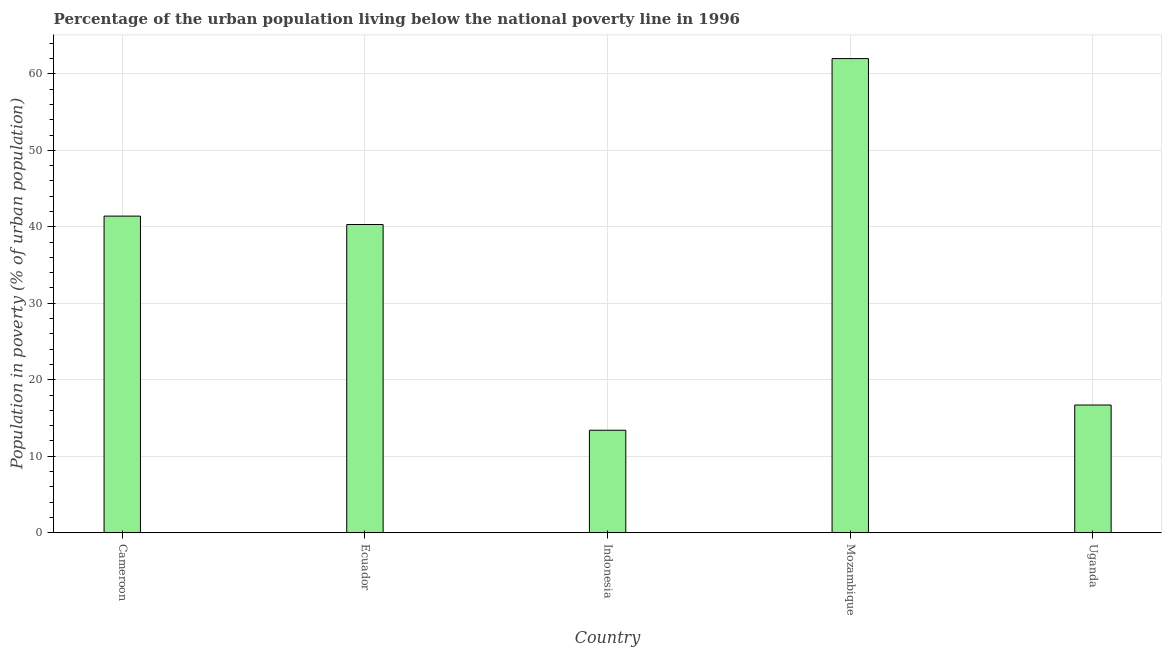Does the graph contain grids?
Make the answer very short. Yes. What is the title of the graph?
Offer a terse response. Percentage of the urban population living below the national poverty line in 1996. What is the label or title of the X-axis?
Offer a very short reply. Country. What is the label or title of the Y-axis?
Offer a terse response. Population in poverty (% of urban population). Across all countries, what is the maximum percentage of urban population living below poverty line?
Provide a short and direct response. 62. Across all countries, what is the minimum percentage of urban population living below poverty line?
Your answer should be compact. 13.4. In which country was the percentage of urban population living below poverty line maximum?
Your response must be concise. Mozambique. In which country was the percentage of urban population living below poverty line minimum?
Your answer should be very brief. Indonesia. What is the sum of the percentage of urban population living below poverty line?
Ensure brevity in your answer.  173.8. What is the difference between the percentage of urban population living below poverty line in Ecuador and Mozambique?
Offer a very short reply. -21.7. What is the average percentage of urban population living below poverty line per country?
Make the answer very short. 34.76. What is the median percentage of urban population living below poverty line?
Give a very brief answer. 40.3. In how many countries, is the percentage of urban population living below poverty line greater than 60 %?
Make the answer very short. 1. What is the ratio of the percentage of urban population living below poverty line in Indonesia to that in Uganda?
Offer a terse response. 0.8. What is the difference between the highest and the second highest percentage of urban population living below poverty line?
Your answer should be very brief. 20.6. What is the difference between the highest and the lowest percentage of urban population living below poverty line?
Provide a succinct answer. 48.6. Are all the bars in the graph horizontal?
Keep it short and to the point. No. How many countries are there in the graph?
Your response must be concise. 5. Are the values on the major ticks of Y-axis written in scientific E-notation?
Provide a succinct answer. No. What is the Population in poverty (% of urban population) in Cameroon?
Offer a very short reply. 41.4. What is the Population in poverty (% of urban population) of Ecuador?
Give a very brief answer. 40.3. What is the Population in poverty (% of urban population) of Mozambique?
Ensure brevity in your answer.  62. What is the Population in poverty (% of urban population) of Uganda?
Your answer should be compact. 16.7. What is the difference between the Population in poverty (% of urban population) in Cameroon and Ecuador?
Your answer should be compact. 1.1. What is the difference between the Population in poverty (% of urban population) in Cameroon and Indonesia?
Offer a terse response. 28. What is the difference between the Population in poverty (% of urban population) in Cameroon and Mozambique?
Make the answer very short. -20.6. What is the difference between the Population in poverty (% of urban population) in Cameroon and Uganda?
Make the answer very short. 24.7. What is the difference between the Population in poverty (% of urban population) in Ecuador and Indonesia?
Give a very brief answer. 26.9. What is the difference between the Population in poverty (% of urban population) in Ecuador and Mozambique?
Ensure brevity in your answer.  -21.7. What is the difference between the Population in poverty (% of urban population) in Ecuador and Uganda?
Your answer should be compact. 23.6. What is the difference between the Population in poverty (% of urban population) in Indonesia and Mozambique?
Provide a succinct answer. -48.6. What is the difference between the Population in poverty (% of urban population) in Mozambique and Uganda?
Provide a succinct answer. 45.3. What is the ratio of the Population in poverty (% of urban population) in Cameroon to that in Indonesia?
Offer a very short reply. 3.09. What is the ratio of the Population in poverty (% of urban population) in Cameroon to that in Mozambique?
Your response must be concise. 0.67. What is the ratio of the Population in poverty (% of urban population) in Cameroon to that in Uganda?
Offer a very short reply. 2.48. What is the ratio of the Population in poverty (% of urban population) in Ecuador to that in Indonesia?
Give a very brief answer. 3.01. What is the ratio of the Population in poverty (% of urban population) in Ecuador to that in Mozambique?
Offer a terse response. 0.65. What is the ratio of the Population in poverty (% of urban population) in Ecuador to that in Uganda?
Provide a short and direct response. 2.41. What is the ratio of the Population in poverty (% of urban population) in Indonesia to that in Mozambique?
Your response must be concise. 0.22. What is the ratio of the Population in poverty (% of urban population) in Indonesia to that in Uganda?
Offer a very short reply. 0.8. What is the ratio of the Population in poverty (% of urban population) in Mozambique to that in Uganda?
Your answer should be very brief. 3.71. 